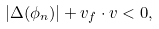<formula> <loc_0><loc_0><loc_500><loc_500>\left | \Delta ( \phi _ { n } ) \right | + { v } _ { f } \cdot { v } < 0 ,</formula> 